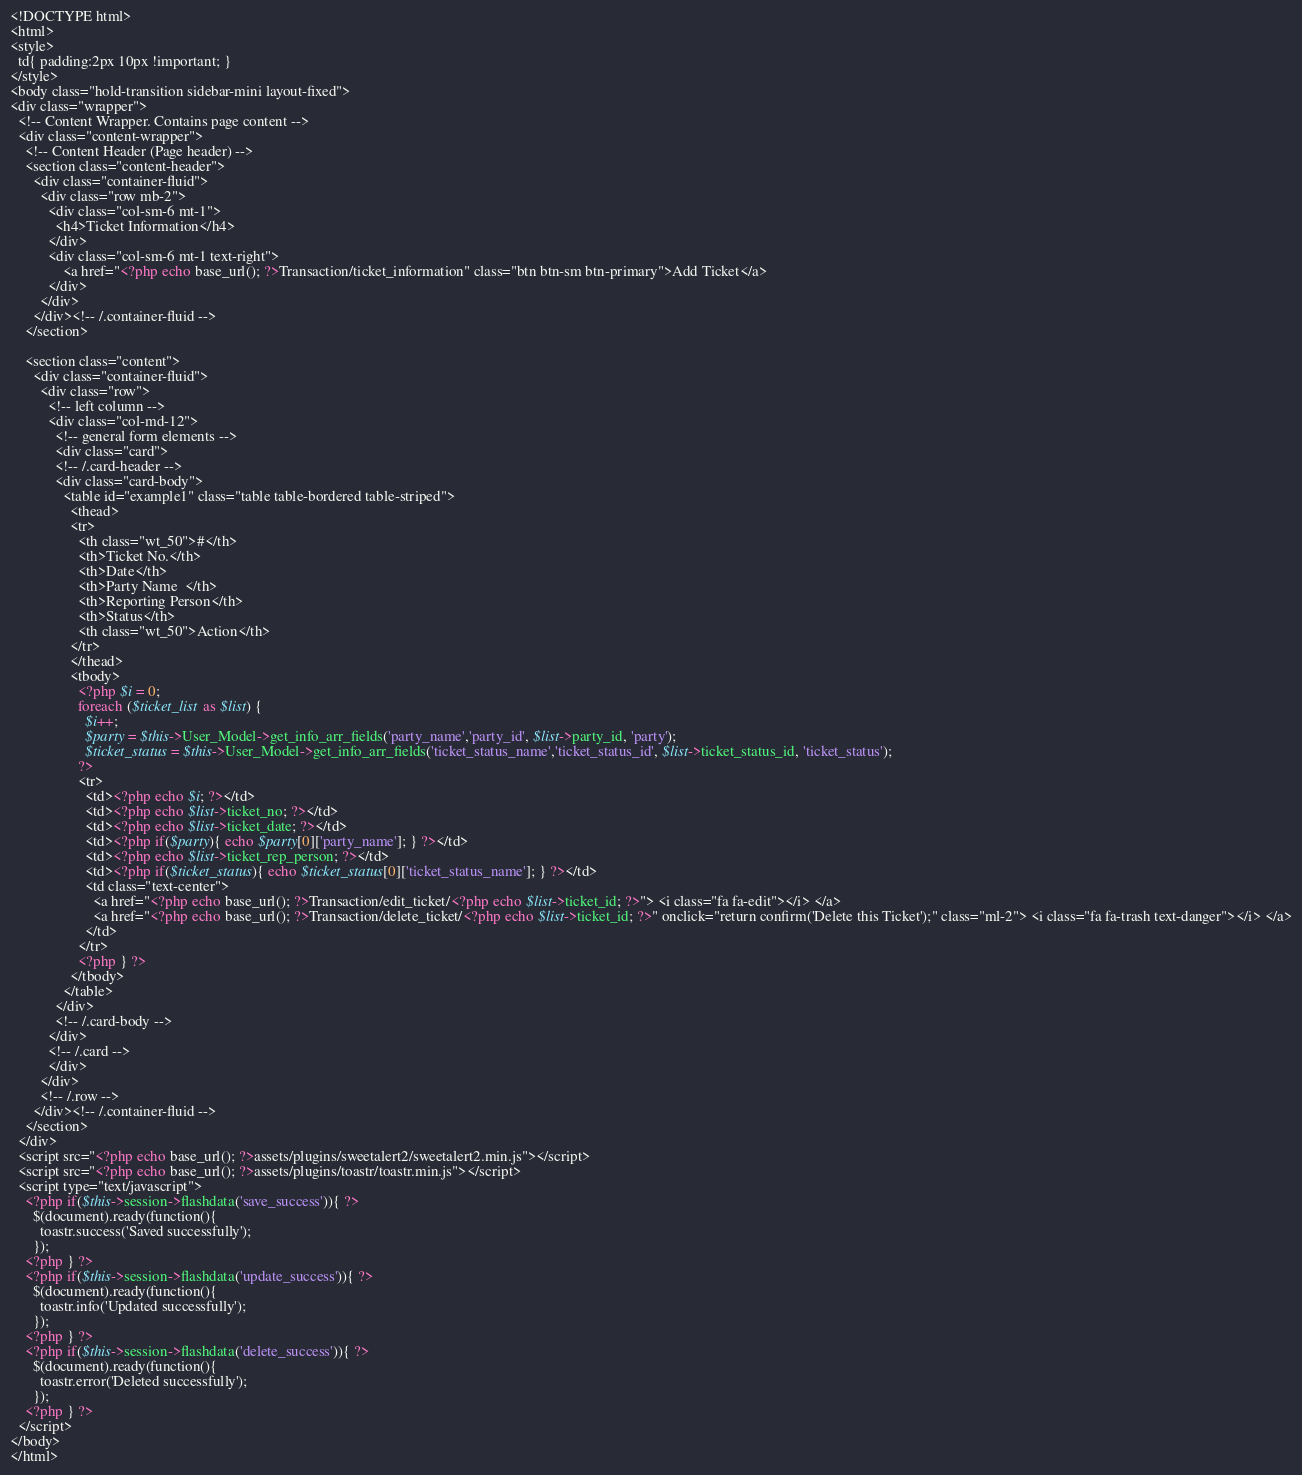<code> <loc_0><loc_0><loc_500><loc_500><_PHP_><!DOCTYPE html>
<html>
<style>
  td{ padding:2px 10px !important; }
</style>
<body class="hold-transition sidebar-mini layout-fixed">
<div class="wrapper">
  <!-- Content Wrapper. Contains page content -->
  <div class="content-wrapper">
    <!-- Content Header (Page header) -->
    <section class="content-header">
      <div class="container-fluid">
        <div class="row mb-2">
          <div class="col-sm-6 mt-1">
            <h4>Ticket Information</h4>
          </div>
          <div class="col-sm-6 mt-1 text-right">
              <a href="<?php echo base_url(); ?>Transaction/ticket_information" class="btn btn-sm btn-primary">Add Ticket</a>
          </div>
        </div>
      </div><!-- /.container-fluid -->
    </section>

    <section class="content">
      <div class="container-fluid">
        <div class="row">
          <!-- left column -->
          <div class="col-md-12">
            <!-- general form elements -->
            <div class="card">
            <!-- /.card-header -->
            <div class="card-body">
              <table id="example1" class="table table-bordered table-striped">
                <thead>
                <tr>
                  <th class="wt_50">#</th>
                  <th>Ticket No.</th>
                  <th>Date</th>
                  <th>Party Name  </th>
                  <th>Reporting Person</th>
                  <th>Status</th>
                  <th class="wt_50">Action</th>
                </tr>
                </thead>
                <tbody>
                  <?php $i = 0;
                  foreach ($ticket_list as $list) {
                    $i++;
                    $party = $this->User_Model->get_info_arr_fields('party_name','party_id', $list->party_id, 'party');
                    $ticket_status = $this->User_Model->get_info_arr_fields('ticket_status_name','ticket_status_id', $list->ticket_status_id, 'ticket_status');
                  ?>
                  <tr>
                    <td><?php echo $i; ?></td>
                    <td><?php echo $list->ticket_no; ?></td>
                    <td><?php echo $list->ticket_date; ?></td>
                    <td><?php if($party){ echo $party[0]['party_name']; } ?></td>
                    <td><?php echo $list->ticket_rep_person; ?></td>
                    <td><?php if($ticket_status){ echo $ticket_status[0]['ticket_status_name']; } ?></td>
                    <td class="text-center">
                      <a href="<?php echo base_url(); ?>Transaction/edit_ticket/<?php echo $list->ticket_id; ?>"> <i class="fa fa-edit"></i> </a>
                      <a href="<?php echo base_url(); ?>Transaction/delete_ticket/<?php echo $list->ticket_id; ?>" onclick="return confirm('Delete this Ticket');" class="ml-2"> <i class="fa fa-trash text-danger"></i> </a>
                    </td>
                  </tr>
                  <?php } ?>
                </tbody>
              </table>
            </div>
            <!-- /.card-body -->
          </div>
          <!-- /.card -->
          </div>
        </div>
        <!-- /.row -->
      </div><!-- /.container-fluid -->
    </section>
  </div>
  <script src="<?php echo base_url(); ?>assets/plugins/sweetalert2/sweetalert2.min.js"></script>
  <script src="<?php echo base_url(); ?>assets/plugins/toastr/toastr.min.js"></script>
  <script type="text/javascript">
    <?php if($this->session->flashdata('save_success')){ ?>
      $(document).ready(function(){
        toastr.success('Saved successfully');
      });
    <?php } ?>
    <?php if($this->session->flashdata('update_success')){ ?>
      $(document).ready(function(){
        toastr.info('Updated successfully');
      });
    <?php } ?>
    <?php if($this->session->flashdata('delete_success')){ ?>
      $(document).ready(function(){
        toastr.error('Deleted successfully');
      });
    <?php } ?>
  </script>
</body>
</html>
</code> 